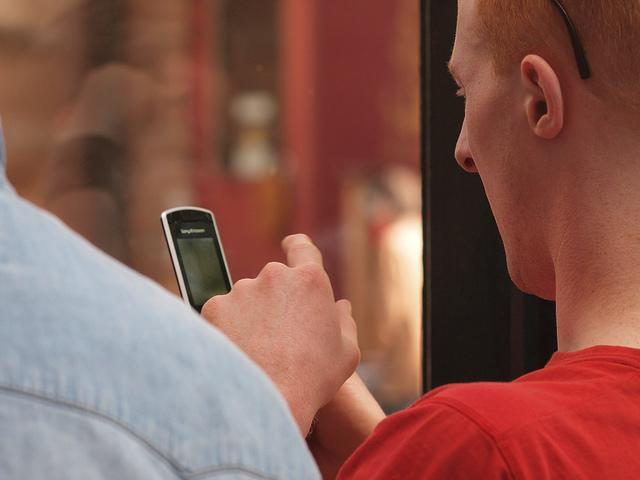The bald man with glasses is using what kind of phone? Please explain your reasoning. flip. It is a phone that folds 